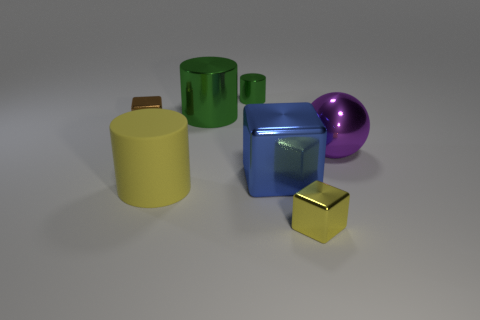The tiny metal object that is in front of the block that is behind the purple ball is what shape?
Offer a very short reply. Cube. There is a cylinder in front of the metal object right of the block in front of the yellow matte thing; what size is it?
Offer a very short reply. Large. The tiny object that is the same shape as the large rubber object is what color?
Ensure brevity in your answer.  Green. Does the yellow rubber cylinder have the same size as the purple metal ball?
Make the answer very short. Yes. There is a block that is behind the big metallic sphere; what is its material?
Your answer should be compact. Metal. What number of other objects are there of the same shape as the purple shiny thing?
Provide a succinct answer. 0. Is the shape of the brown thing the same as the blue thing?
Your answer should be compact. Yes. There is a big green shiny thing; are there any large rubber objects behind it?
Make the answer very short. No. What number of objects are yellow rubber cylinders or small rubber spheres?
Provide a succinct answer. 1. What number of other objects are the same size as the blue thing?
Provide a short and direct response. 3. 